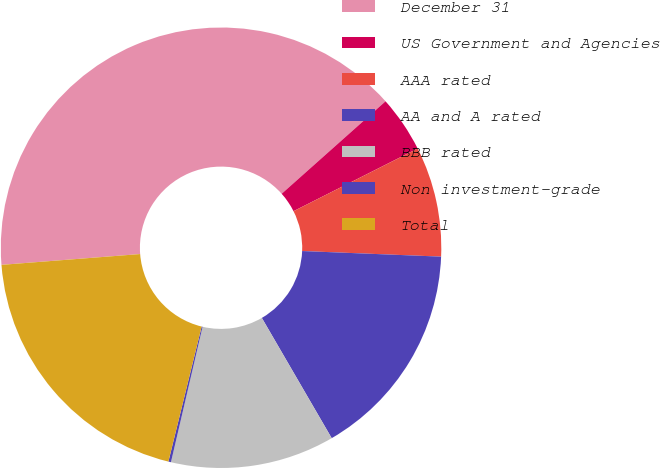<chart> <loc_0><loc_0><loc_500><loc_500><pie_chart><fcel>December 31<fcel>US Government and Agencies<fcel>AAA rated<fcel>AA and A rated<fcel>BBB rated<fcel>Non investment-grade<fcel>Total<nl><fcel>39.66%<fcel>4.14%<fcel>8.08%<fcel>15.98%<fcel>12.03%<fcel>0.19%<fcel>19.92%<nl></chart> 